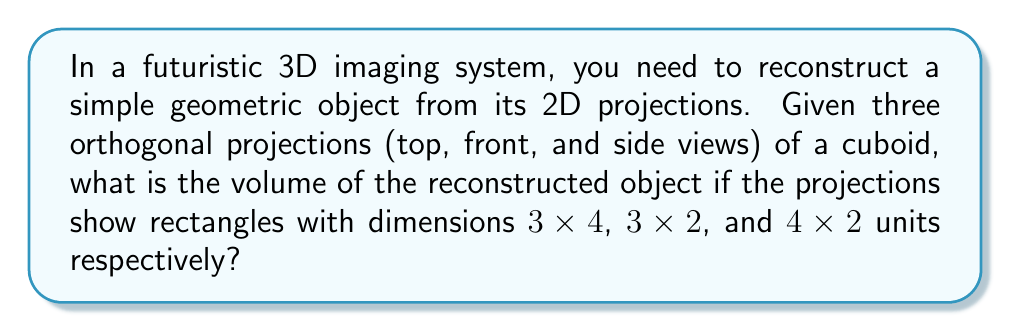Provide a solution to this math problem. Let's approach this step-by-step:

1) In 3D reconstruction from orthogonal projections, each projection represents the maximum extent of the object in two dimensions.

2) The three projections given are:
   - Top view: 3x4 units
   - Front view: 3x2 units
   - Side view: 4x2 units

3) From these projections, we can deduce the dimensions of the cuboid:
   - Length (l) = 4 units (from top and side views)
   - Width (w) = 3 units (from top and front views)
   - Height (h) = 2 units (from front and side views)

4) The volume of a cuboid is given by the formula:

   $$ V = l \times w \times h $$

5) Substituting the values:

   $$ V = 4 \times 3 \times 2 $$

6) Calculating:

   $$ V = 24 $$

Therefore, the volume of the reconstructed cuboid is 24 cubic units.
Answer: 24 cubic units 